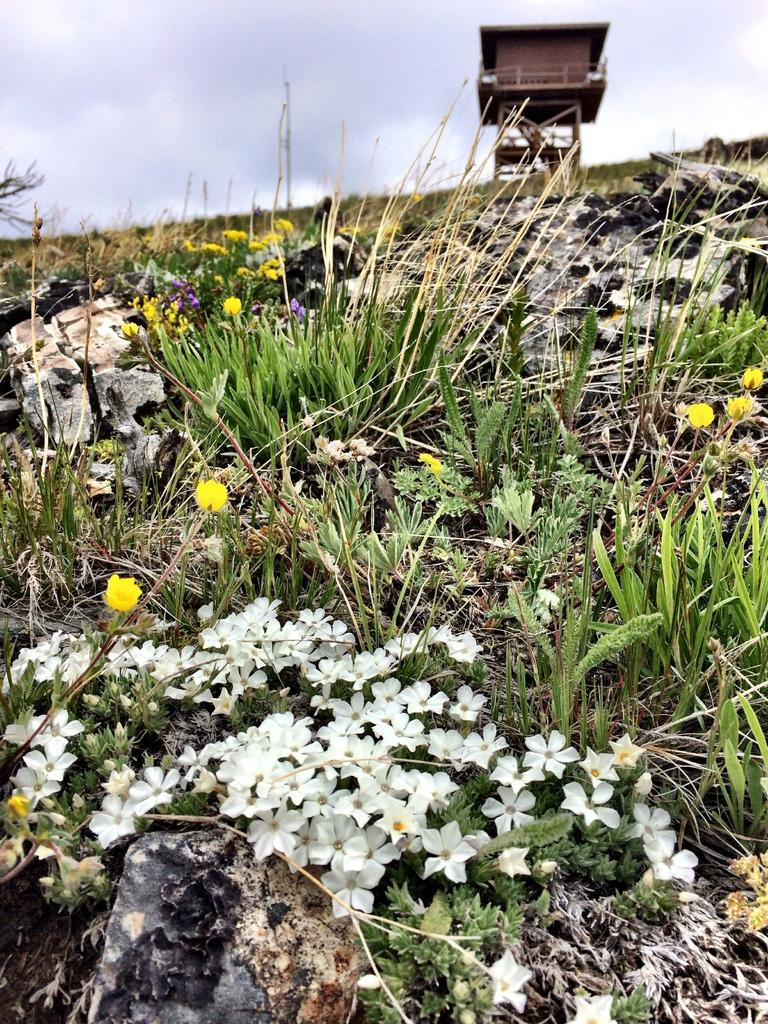What types of vegetation can be seen in the image? There are plants and flowers in the image. What structure is visible in the background of the image? There is a tower in the background of the image. What can be seen in the sky in the image? There are clouds visible in the background of the image. Can you see any stars in the image? There are no stars visible in the image; only clouds can be seen in the sky. 